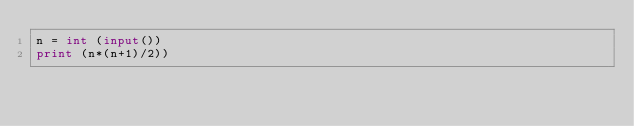<code> <loc_0><loc_0><loc_500><loc_500><_Python_>n = int (input())
print (n*(n+1)/2))
</code> 